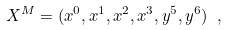Convert formula to latex. <formula><loc_0><loc_0><loc_500><loc_500>X ^ { M } = ( x ^ { 0 } , x ^ { 1 } , x ^ { 2 } , x ^ { 3 } , y ^ { 5 } , y ^ { 6 } ) \ ,</formula> 